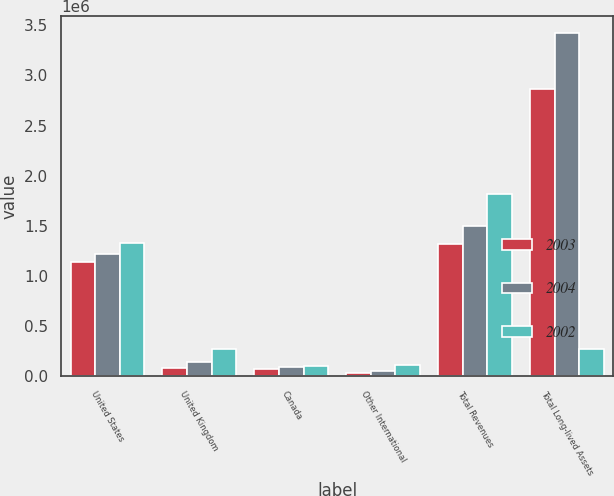<chart> <loc_0><loc_0><loc_500><loc_500><stacked_bar_chart><ecel><fcel>United States<fcel>United Kingdom<fcel>Canada<fcel>Other International<fcel>Total Revenues<fcel>Total Long-lived Assets<nl><fcel>2003<fcel>1.134e+06<fcel>79228<fcel>75116<fcel>30153<fcel>1.3185e+06<fcel>2.86362e+06<nl><fcel>2004<fcel>1.21567e+06<fcel>145735<fcel>87592<fcel>52333<fcel>1.50133e+06<fcel>3.42052e+06<nl><fcel>2002<fcel>1.33098e+06<fcel>270665<fcel>106577<fcel>109368<fcel>1.81759e+06<fcel>270665<nl></chart> 